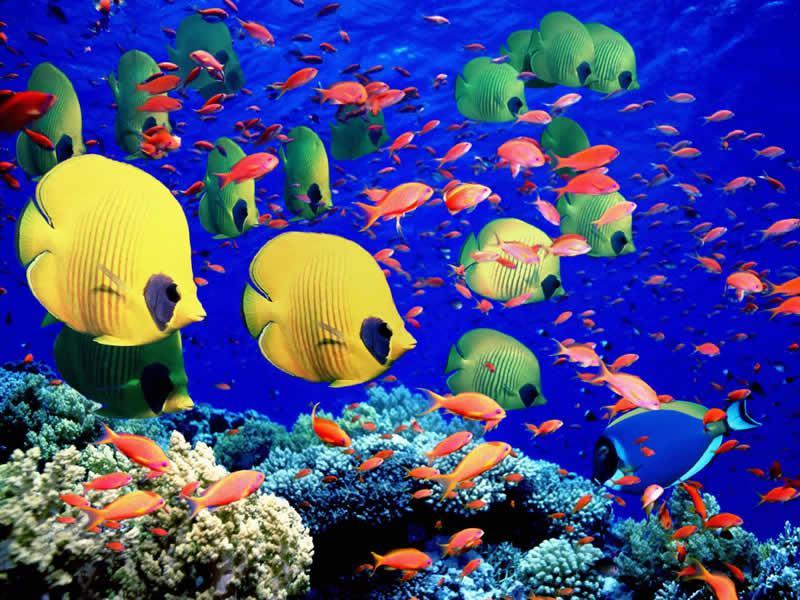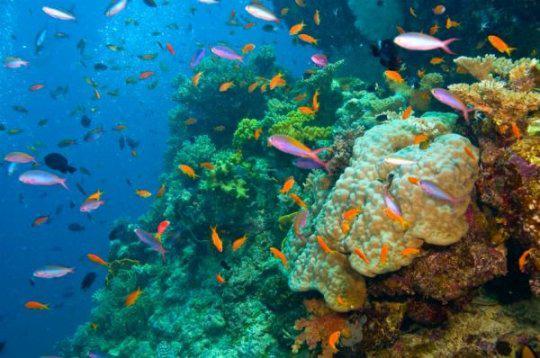The first image is the image on the left, the second image is the image on the right. For the images displayed, is the sentence "There is a single clownfish swimming by the reef." factually correct? Answer yes or no. No. 